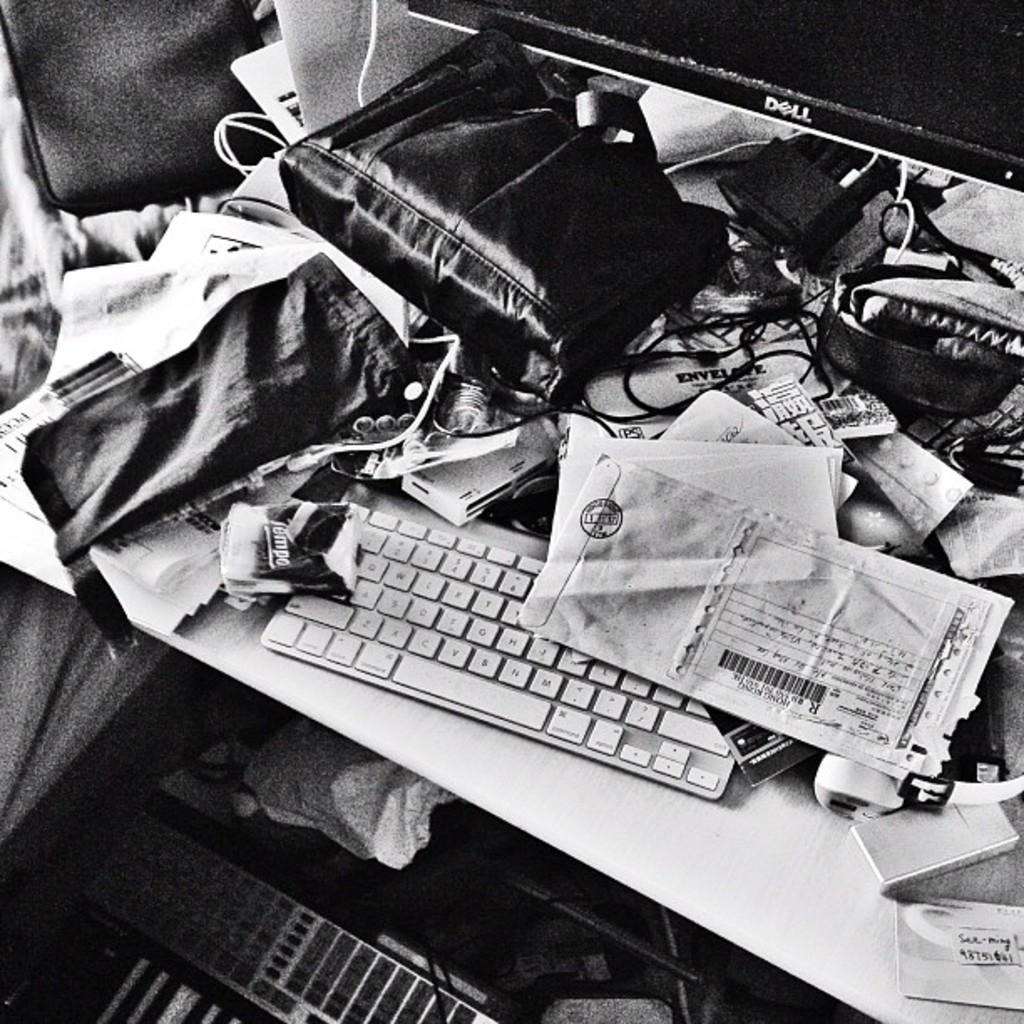What electronic device is on the table in the image? There is a computer on the table in the image. What else can be seen on the table besides the computer? There is a bag, papers, and other objects on the table in the image. Can you describe the object at the bottom of the image? Unfortunately, there is no information about an object at the bottom of the image. What might be the purpose of the papers on the table? The papers on the table might be used for work, study, or other purposes. What type of slope can be seen in the image? There is no slope present in the image. What kind of flag is visible in the image? There is no flag present in the image. 